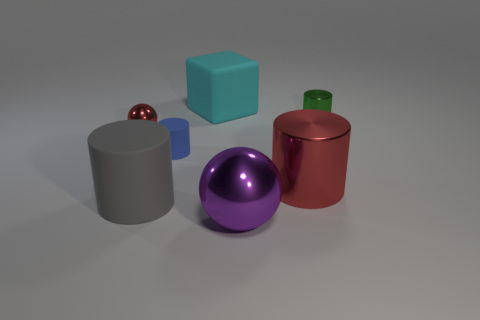There is a large cylinder to the left of the metal thing that is in front of the big gray matte thing; what number of red metal things are right of it?
Offer a very short reply. 1. Does the big metallic cylinder have the same color as the big matte cylinder?
Ensure brevity in your answer.  No. How many objects are to the left of the tiny green thing and in front of the large cyan block?
Provide a succinct answer. 5. There is a metallic thing that is left of the large cube; what shape is it?
Your response must be concise. Sphere. Are there fewer large purple balls that are behind the purple metal sphere than small green metal cylinders in front of the big metal cylinder?
Give a very brief answer. No. Are the tiny cylinder right of the big purple object and the tiny red object that is left of the blue matte object made of the same material?
Provide a succinct answer. Yes. What is the shape of the large purple shiny object?
Give a very brief answer. Sphere. Are there more tiny rubber objects that are in front of the big red metal cylinder than big things behind the cyan rubber cube?
Provide a succinct answer. No. Is the shape of the large cyan matte thing behind the big red cylinder the same as the tiny blue thing behind the red metal cylinder?
Make the answer very short. No. What number of other things are the same size as the block?
Make the answer very short. 3. 